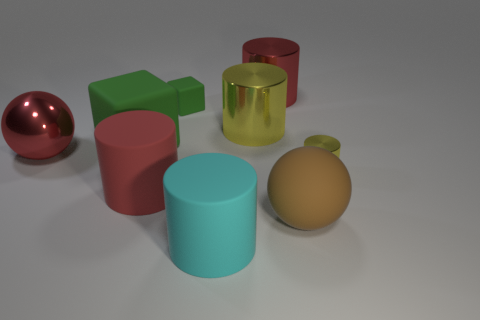There is a yellow thing that is in front of the big red shiny thing that is in front of the red metallic cylinder; what is its size?
Your response must be concise. Small. Are there an equal number of metallic cylinders that are to the left of the large yellow object and metallic objects to the right of the brown matte ball?
Provide a short and direct response. No. There is a tiny thing that is made of the same material as the large block; what is its color?
Provide a succinct answer. Green. Is the tiny yellow object made of the same material as the red object on the left side of the big red rubber object?
Keep it short and to the point. Yes. What is the color of the metallic cylinder that is both in front of the tiny green rubber cube and on the left side of the small yellow thing?
Make the answer very short. Yellow. What number of spheres are either rubber things or tiny blue rubber objects?
Your response must be concise. 1. Is the shape of the large brown thing the same as the red shiny object right of the large cyan rubber thing?
Keep it short and to the point. No. What size is the metallic thing that is in front of the big green object and on the right side of the large metal sphere?
Offer a terse response. Small. There is a tiny metallic thing; what shape is it?
Your answer should be very brief. Cylinder. Are there any tiny objects that are right of the ball that is right of the cyan rubber cylinder?
Offer a terse response. Yes. 